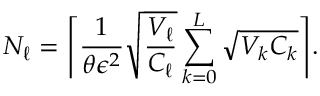Convert formula to latex. <formula><loc_0><loc_0><loc_500><loc_500>N _ { \ell } = \left \lceil \frac { 1 } { \theta \epsilon ^ { 2 } } \sqrt { \frac { V _ { \ell } } { C _ { \ell } } } \sum _ { k = 0 } ^ { L } \sqrt { V _ { k } C _ { k } } \right \rceil .</formula> 